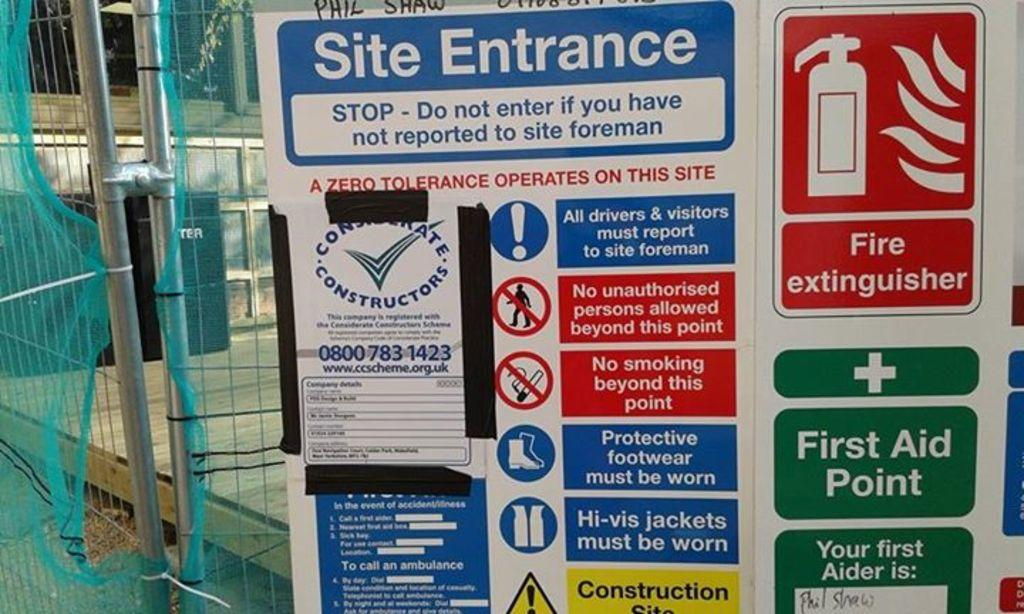Provide a one-sentence caption for the provided image. a colorful board with a site entrance on it. 